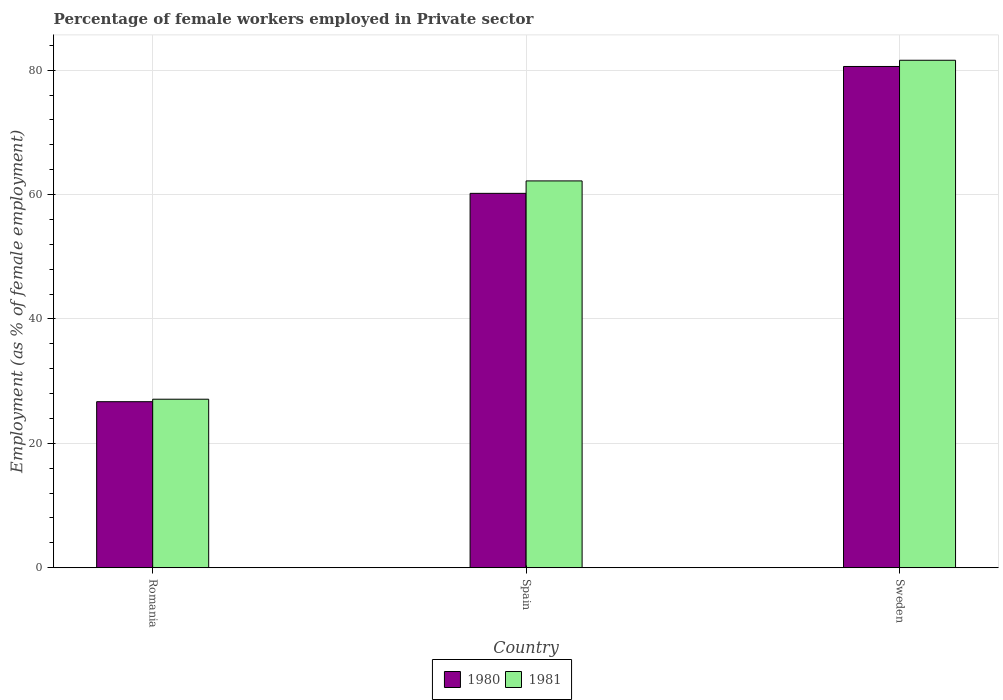Are the number of bars on each tick of the X-axis equal?
Offer a terse response. Yes. How many bars are there on the 1st tick from the left?
Provide a succinct answer. 2. How many bars are there on the 3rd tick from the right?
Your response must be concise. 2. What is the label of the 2nd group of bars from the left?
Your answer should be very brief. Spain. In how many cases, is the number of bars for a given country not equal to the number of legend labels?
Offer a terse response. 0. What is the percentage of females employed in Private sector in 1980 in Spain?
Provide a short and direct response. 60.2. Across all countries, what is the maximum percentage of females employed in Private sector in 1980?
Give a very brief answer. 80.6. Across all countries, what is the minimum percentage of females employed in Private sector in 1981?
Keep it short and to the point. 27.1. In which country was the percentage of females employed in Private sector in 1981 minimum?
Ensure brevity in your answer.  Romania. What is the total percentage of females employed in Private sector in 1981 in the graph?
Your answer should be very brief. 170.9. What is the difference between the percentage of females employed in Private sector in 1980 in Romania and that in Sweden?
Your answer should be compact. -53.9. What is the difference between the percentage of females employed in Private sector in 1980 in Romania and the percentage of females employed in Private sector in 1981 in Spain?
Make the answer very short. -35.5. What is the average percentage of females employed in Private sector in 1980 per country?
Offer a very short reply. 55.83. What is the difference between the percentage of females employed in Private sector of/in 1981 and percentage of females employed in Private sector of/in 1980 in Romania?
Your answer should be compact. 0.4. What is the ratio of the percentage of females employed in Private sector in 1981 in Spain to that in Sweden?
Provide a succinct answer. 0.76. What is the difference between the highest and the second highest percentage of females employed in Private sector in 1980?
Offer a very short reply. 53.9. What is the difference between the highest and the lowest percentage of females employed in Private sector in 1980?
Provide a succinct answer. 53.9. What does the 2nd bar from the right in Romania represents?
Your answer should be compact. 1980. How many bars are there?
Provide a short and direct response. 6. How many countries are there in the graph?
Provide a succinct answer. 3. Does the graph contain grids?
Provide a short and direct response. Yes. How many legend labels are there?
Provide a succinct answer. 2. How are the legend labels stacked?
Your response must be concise. Horizontal. What is the title of the graph?
Ensure brevity in your answer.  Percentage of female workers employed in Private sector. Does "1964" appear as one of the legend labels in the graph?
Your answer should be very brief. No. What is the label or title of the X-axis?
Provide a short and direct response. Country. What is the label or title of the Y-axis?
Offer a very short reply. Employment (as % of female employment). What is the Employment (as % of female employment) of 1980 in Romania?
Provide a succinct answer. 26.7. What is the Employment (as % of female employment) of 1981 in Romania?
Offer a terse response. 27.1. What is the Employment (as % of female employment) of 1980 in Spain?
Provide a short and direct response. 60.2. What is the Employment (as % of female employment) in 1981 in Spain?
Offer a terse response. 62.2. What is the Employment (as % of female employment) in 1980 in Sweden?
Offer a terse response. 80.6. What is the Employment (as % of female employment) in 1981 in Sweden?
Give a very brief answer. 81.6. Across all countries, what is the maximum Employment (as % of female employment) in 1980?
Make the answer very short. 80.6. Across all countries, what is the maximum Employment (as % of female employment) of 1981?
Keep it short and to the point. 81.6. Across all countries, what is the minimum Employment (as % of female employment) in 1980?
Your answer should be very brief. 26.7. Across all countries, what is the minimum Employment (as % of female employment) of 1981?
Provide a succinct answer. 27.1. What is the total Employment (as % of female employment) of 1980 in the graph?
Keep it short and to the point. 167.5. What is the total Employment (as % of female employment) of 1981 in the graph?
Provide a succinct answer. 170.9. What is the difference between the Employment (as % of female employment) in 1980 in Romania and that in Spain?
Offer a very short reply. -33.5. What is the difference between the Employment (as % of female employment) of 1981 in Romania and that in Spain?
Provide a succinct answer. -35.1. What is the difference between the Employment (as % of female employment) of 1980 in Romania and that in Sweden?
Offer a very short reply. -53.9. What is the difference between the Employment (as % of female employment) in 1981 in Romania and that in Sweden?
Offer a terse response. -54.5. What is the difference between the Employment (as % of female employment) of 1980 in Spain and that in Sweden?
Your answer should be compact. -20.4. What is the difference between the Employment (as % of female employment) of 1981 in Spain and that in Sweden?
Provide a succinct answer. -19.4. What is the difference between the Employment (as % of female employment) of 1980 in Romania and the Employment (as % of female employment) of 1981 in Spain?
Your answer should be compact. -35.5. What is the difference between the Employment (as % of female employment) of 1980 in Romania and the Employment (as % of female employment) of 1981 in Sweden?
Provide a short and direct response. -54.9. What is the difference between the Employment (as % of female employment) of 1980 in Spain and the Employment (as % of female employment) of 1981 in Sweden?
Your response must be concise. -21.4. What is the average Employment (as % of female employment) of 1980 per country?
Offer a very short reply. 55.83. What is the average Employment (as % of female employment) of 1981 per country?
Ensure brevity in your answer.  56.97. What is the difference between the Employment (as % of female employment) of 1980 and Employment (as % of female employment) of 1981 in Spain?
Offer a terse response. -2. What is the difference between the Employment (as % of female employment) in 1980 and Employment (as % of female employment) in 1981 in Sweden?
Offer a terse response. -1. What is the ratio of the Employment (as % of female employment) of 1980 in Romania to that in Spain?
Offer a very short reply. 0.44. What is the ratio of the Employment (as % of female employment) of 1981 in Romania to that in Spain?
Make the answer very short. 0.44. What is the ratio of the Employment (as % of female employment) of 1980 in Romania to that in Sweden?
Your response must be concise. 0.33. What is the ratio of the Employment (as % of female employment) of 1981 in Romania to that in Sweden?
Make the answer very short. 0.33. What is the ratio of the Employment (as % of female employment) of 1980 in Spain to that in Sweden?
Give a very brief answer. 0.75. What is the ratio of the Employment (as % of female employment) of 1981 in Spain to that in Sweden?
Offer a very short reply. 0.76. What is the difference between the highest and the second highest Employment (as % of female employment) of 1980?
Keep it short and to the point. 20.4. What is the difference between the highest and the lowest Employment (as % of female employment) in 1980?
Provide a short and direct response. 53.9. What is the difference between the highest and the lowest Employment (as % of female employment) in 1981?
Your response must be concise. 54.5. 